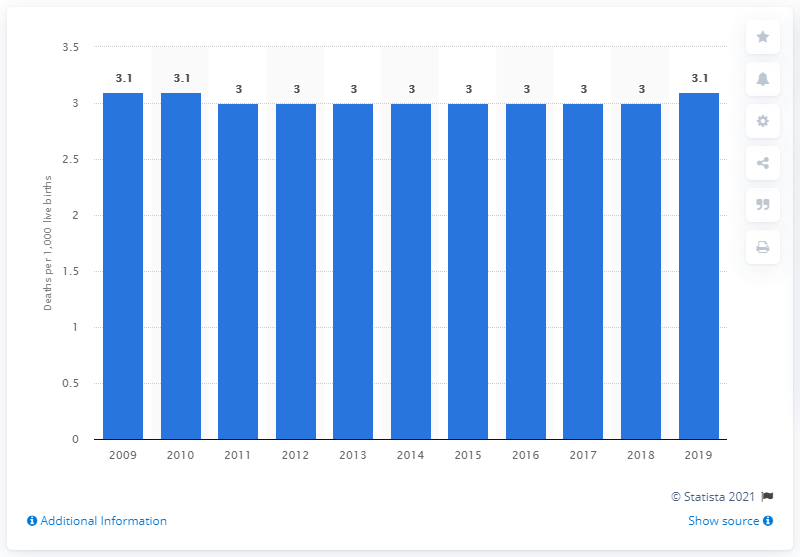Highlight a few significant elements in this photo. The infant mortality rate in Portugal in 2019 was 3.1 deaths per 1,000 live births. 